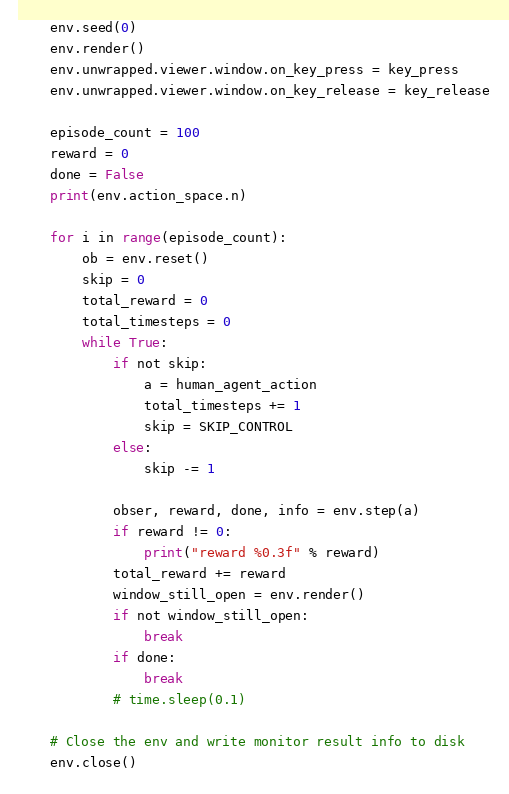<code> <loc_0><loc_0><loc_500><loc_500><_Python_>    env.seed(0)
    env.render()
    env.unwrapped.viewer.window.on_key_press = key_press
    env.unwrapped.viewer.window.on_key_release = key_release

    episode_count = 100
    reward = 0
    done = False
    print(env.action_space.n)

    for i in range(episode_count):
        ob = env.reset()
        skip = 0
        total_reward = 0
        total_timesteps = 0
        while True:
            if not skip:
                a = human_agent_action
                total_timesteps += 1
                skip = SKIP_CONTROL
            else:
                skip -= 1

            obser, reward, done, info = env.step(a)
            if reward != 0:
                print("reward %0.3f" % reward)
            total_reward += reward
            window_still_open = env.render()
            if not window_still_open:
                break
            if done:
                break
            # time.sleep(0.1)

    # Close the env and write monitor result info to disk
    env.close()
</code> 